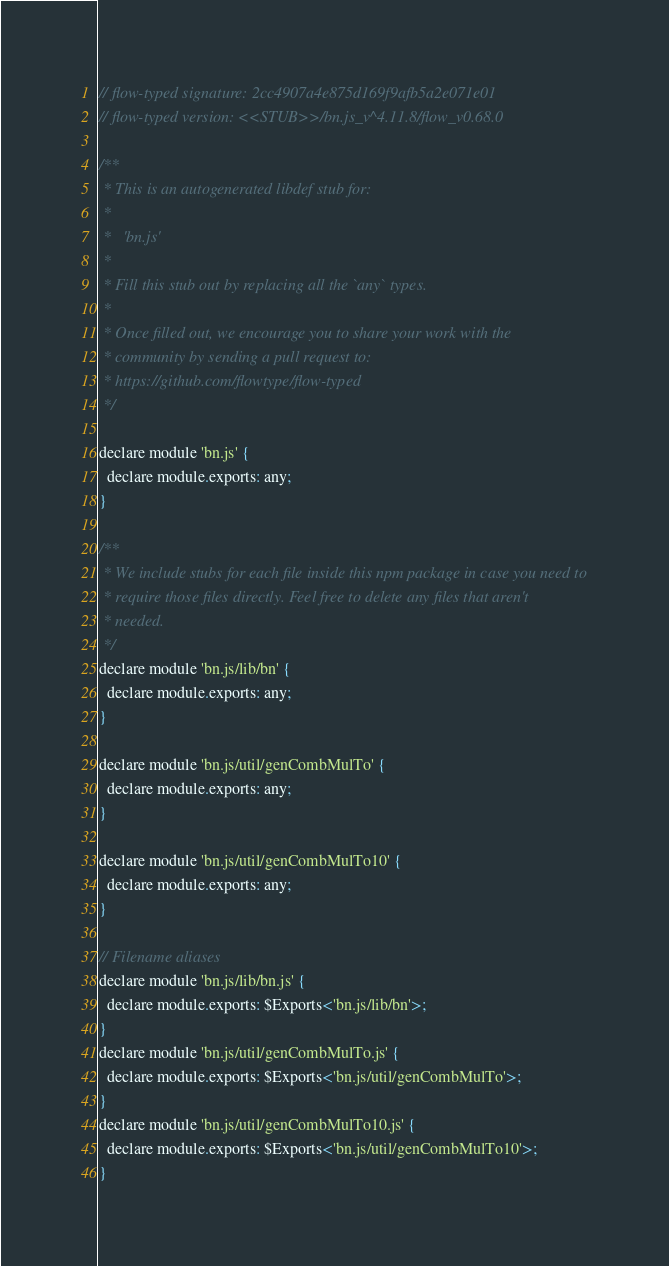Convert code to text. <code><loc_0><loc_0><loc_500><loc_500><_JavaScript_>// flow-typed signature: 2cc4907a4e875d169f9afb5a2e071e01
// flow-typed version: <<STUB>>/bn.js_v^4.11.8/flow_v0.68.0

/**
 * This is an autogenerated libdef stub for:
 *
 *   'bn.js'
 *
 * Fill this stub out by replacing all the `any` types.
 *
 * Once filled out, we encourage you to share your work with the
 * community by sending a pull request to:
 * https://github.com/flowtype/flow-typed
 */

declare module 'bn.js' {
  declare module.exports: any;
}

/**
 * We include stubs for each file inside this npm package in case you need to
 * require those files directly. Feel free to delete any files that aren't
 * needed.
 */
declare module 'bn.js/lib/bn' {
  declare module.exports: any;
}

declare module 'bn.js/util/genCombMulTo' {
  declare module.exports: any;
}

declare module 'bn.js/util/genCombMulTo10' {
  declare module.exports: any;
}

// Filename aliases
declare module 'bn.js/lib/bn.js' {
  declare module.exports: $Exports<'bn.js/lib/bn'>;
}
declare module 'bn.js/util/genCombMulTo.js' {
  declare module.exports: $Exports<'bn.js/util/genCombMulTo'>;
}
declare module 'bn.js/util/genCombMulTo10.js' {
  declare module.exports: $Exports<'bn.js/util/genCombMulTo10'>;
}
</code> 